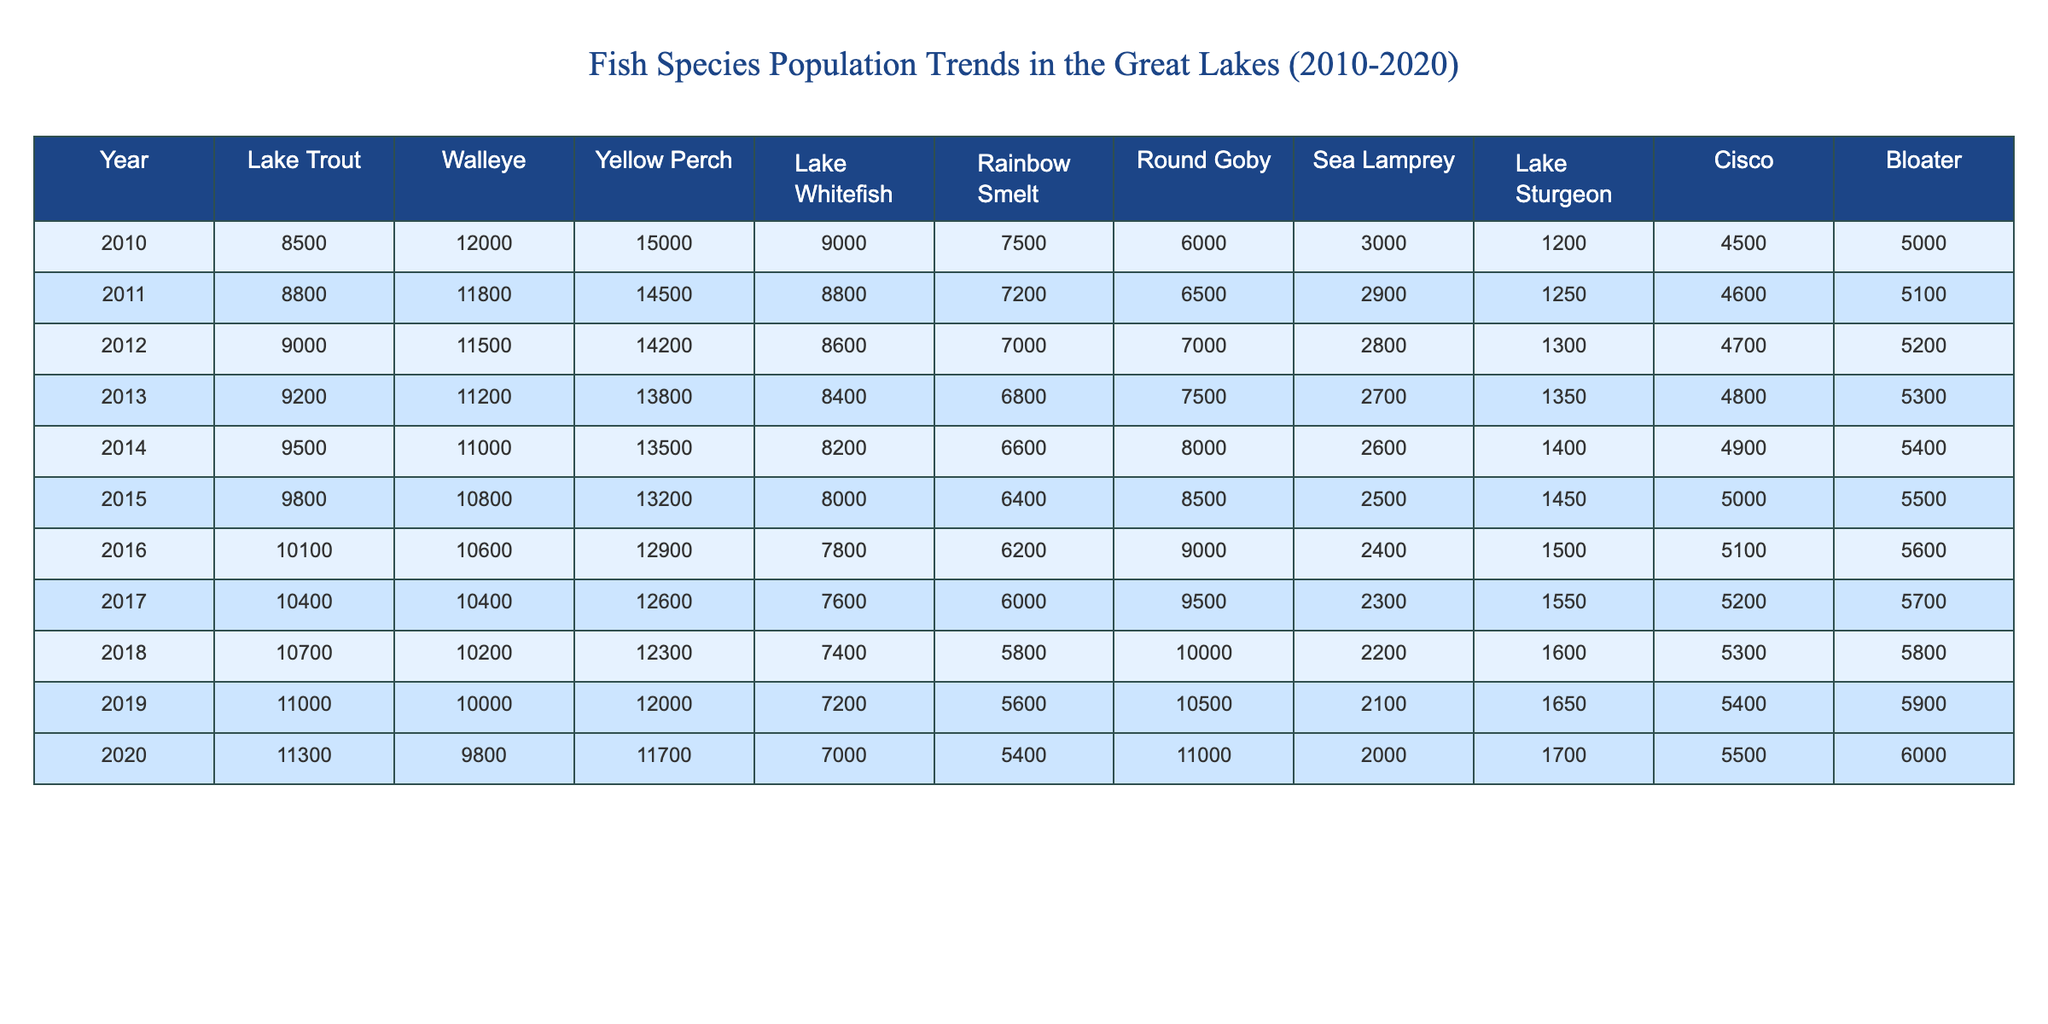What was the fish species with the highest population in 2010? In 2010, Lake Trout had a population of 8500, Walleye had 12000, Yellow Perch had 15000, Lake Whitefish had 9000, Rainbow Smelt had 7500, Round Goby had 6000, Sea Lamprey had 3000, Lake Sturgeon had 1200, Cisco had 4500, and Bloater had 5000. Among these, Yellow Perch had the highest population at 15000.
Answer: Yellow Perch What is the percentage increase in the Lake Sturgeon population from 2010 to 2020? The population of Lake Sturgeon in 2010 was 1200 and in 2020 it was 1700. To find the percentage increase: ((1700 - 1200) / 1200) * 100 = (500 / 1200) * 100 ≈ 41.67%.
Answer: Approximately 41.67% Did the population of Walleye decrease from 2010 to 2020? In 2010, Walleye had a population of 12000, and by 2020 it decreased to 9800. This shows a decrease in population.
Answer: Yes Which fish species had the most consistent population decline from 2010 to 2019? By analyzing the data, Walleye shows a steady decline from 12000 in 2010 to 10000 in 2019, a decrease of 2000 over 9 years. Lake Trout also decreased but with fewer fluctuations. Comparatively, Walleye had more consistent decreases year-over-year.
Answer: Walleye What is the average population of Cisco over the ten years? The Cisco populations from 2010 to 2020 are 4500, 4600, 4700, 4800, 4900, 5000, 5100, 5200, 5400, and 5500. Summing these values gives 48600. Dividing by the number of years (10) gives an average of 48600 / 10 = 4860.
Answer: 4860 What fish species showed the highest increase in population between 2010 and 2020? By comparing the populations, we see Rainbow Smelt increased from 7500 in 2010 to 5400 in 2020, a change of -2100. However, Round Goby increased from 6000 to 11000, an increase of 5000. This makes Round Goby the species with the highest increase in population over the decade.
Answer: Round Goby Is it true that Lake Trout had a higher population than Bloater in 2015? In 2015, Lake Trout had a population of 9800 while Bloater had 5500. Since 9800 is greater than 5500, this statement is true.
Answer: Yes What was the total population of all fish species combined in 2014? Summing up the populations in 2014 gives us: 9500 (Lake Trout) + 11000 (Walleye) + 13500 (Yellow Perch) + 8200 (Lake Whitefish) + 6600 (Rainbow Smelt) + 8000 (Round Goby) + 2600 (Sea Lamprey) + 1400 (Lake Sturgeon) + 4900 (Cisco) + 5400 (Bloater) = 47100.
Answer: 47100 How did the Yellow Perch population trend from 2010 to 2020? The population of Yellow Perch decreased from 15000 in 2010 to 11700 in 2020. This indicates a downward trend overall from 2010 to 2020 as there are fewer Yellow Perch each year.
Answer: Decreasing trend What was the range of the Walleye population between 2010 and 2020? The range is found by subtracting the minimum value (9800 in 2020) from the maximum value (12000 in 2010): 12000 - 9800 = 2200.
Answer: 2200 